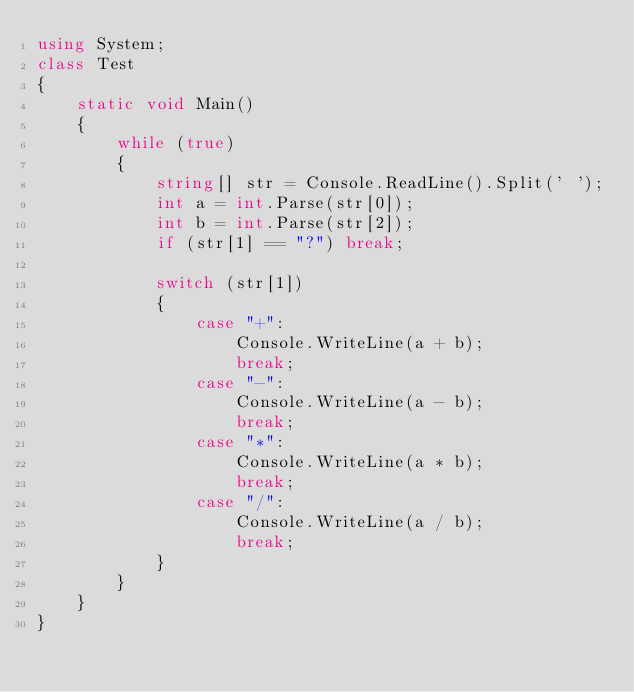<code> <loc_0><loc_0><loc_500><loc_500><_C#_>using System;
class Test
{
    static void Main()
    {
        while (true)
        {
            string[] str = Console.ReadLine().Split(' ');
            int a = int.Parse(str[0]);
            int b = int.Parse(str[2]);
            if (str[1] == "?") break;
 
            switch (str[1])
            {
                case "+":
                    Console.WriteLine(a + b);
                    break;
                case "-":
                    Console.WriteLine(a - b);
                    break;
                case "*":
                    Console.WriteLine(a * b);
                    break;
                case "/":
                    Console.WriteLine(a / b);
                    break;
            }
        }
    }
}</code> 